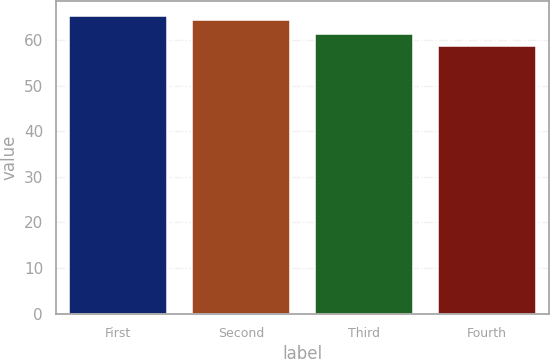Convert chart to OTSL. <chart><loc_0><loc_0><loc_500><loc_500><bar_chart><fcel>First<fcel>Second<fcel>Third<fcel>Fourth<nl><fcel>65.19<fcel>64.37<fcel>61.21<fcel>58.7<nl></chart> 